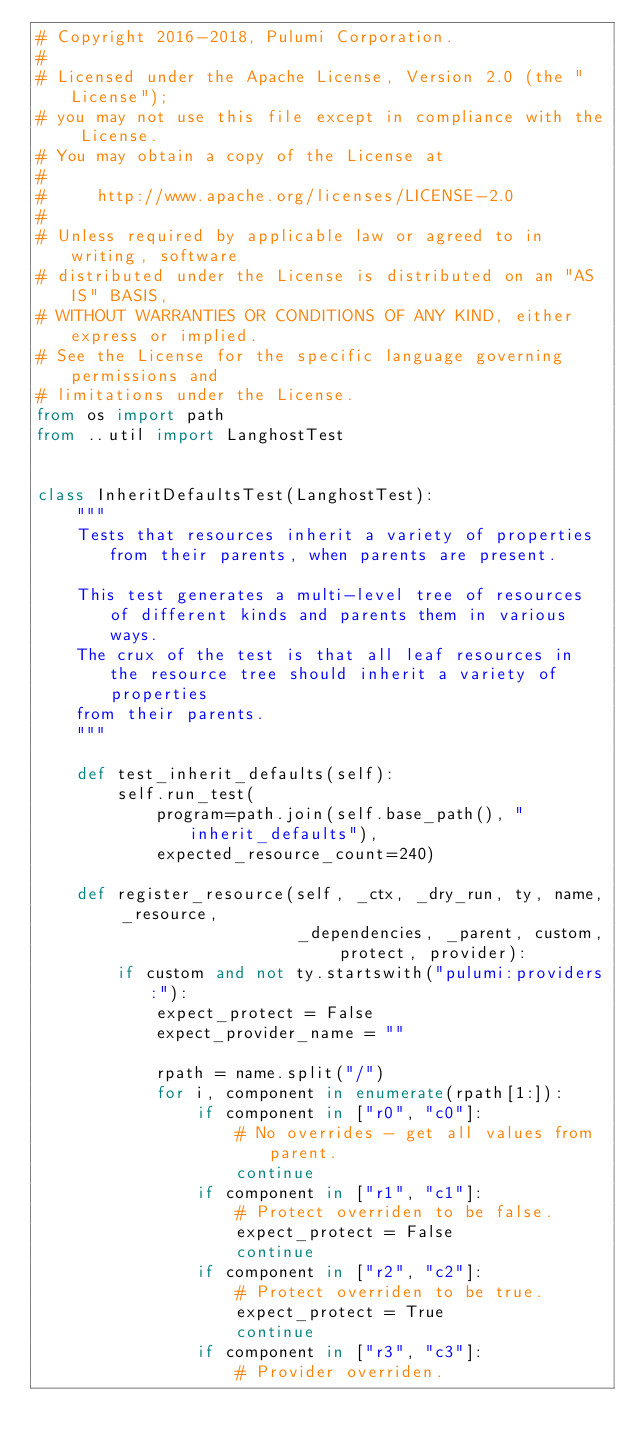Convert code to text. <code><loc_0><loc_0><loc_500><loc_500><_Python_># Copyright 2016-2018, Pulumi Corporation.
#
# Licensed under the Apache License, Version 2.0 (the "License");
# you may not use this file except in compliance with the License.
# You may obtain a copy of the License at
#
#     http://www.apache.org/licenses/LICENSE-2.0
#
# Unless required by applicable law or agreed to in writing, software
# distributed under the License is distributed on an "AS IS" BASIS,
# WITHOUT WARRANTIES OR CONDITIONS OF ANY KIND, either express or implied.
# See the License for the specific language governing permissions and
# limitations under the License.
from os import path
from ..util import LanghostTest


class InheritDefaultsTest(LanghostTest):
    """
    Tests that resources inherit a variety of properties from their parents, when parents are present.

    This test generates a multi-level tree of resources of different kinds and parents them in various ways.
    The crux of the test is that all leaf resources in the resource tree should inherit a variety of properties
    from their parents.
    """

    def test_inherit_defaults(self):
        self.run_test(
            program=path.join(self.base_path(), "inherit_defaults"),
            expected_resource_count=240)

    def register_resource(self, _ctx, _dry_run, ty, name, _resource,
                          _dependencies, _parent, custom, protect, provider):
        if custom and not ty.startswith("pulumi:providers:"):
            expect_protect = False
            expect_provider_name = ""

            rpath = name.split("/")
            for i, component in enumerate(rpath[1:]):
                if component in ["r0", "c0"]:
                    # No overrides - get all values from parent.
                    continue
                if component in ["r1", "c1"]:
                    # Protect overriden to be false.
                    expect_protect = False
                    continue
                if component in ["r2", "c2"]:
                    # Protect overriden to be true.
                    expect_protect = True
                    continue
                if component in ["r3", "c3"]:
                    # Provider overriden.</code> 